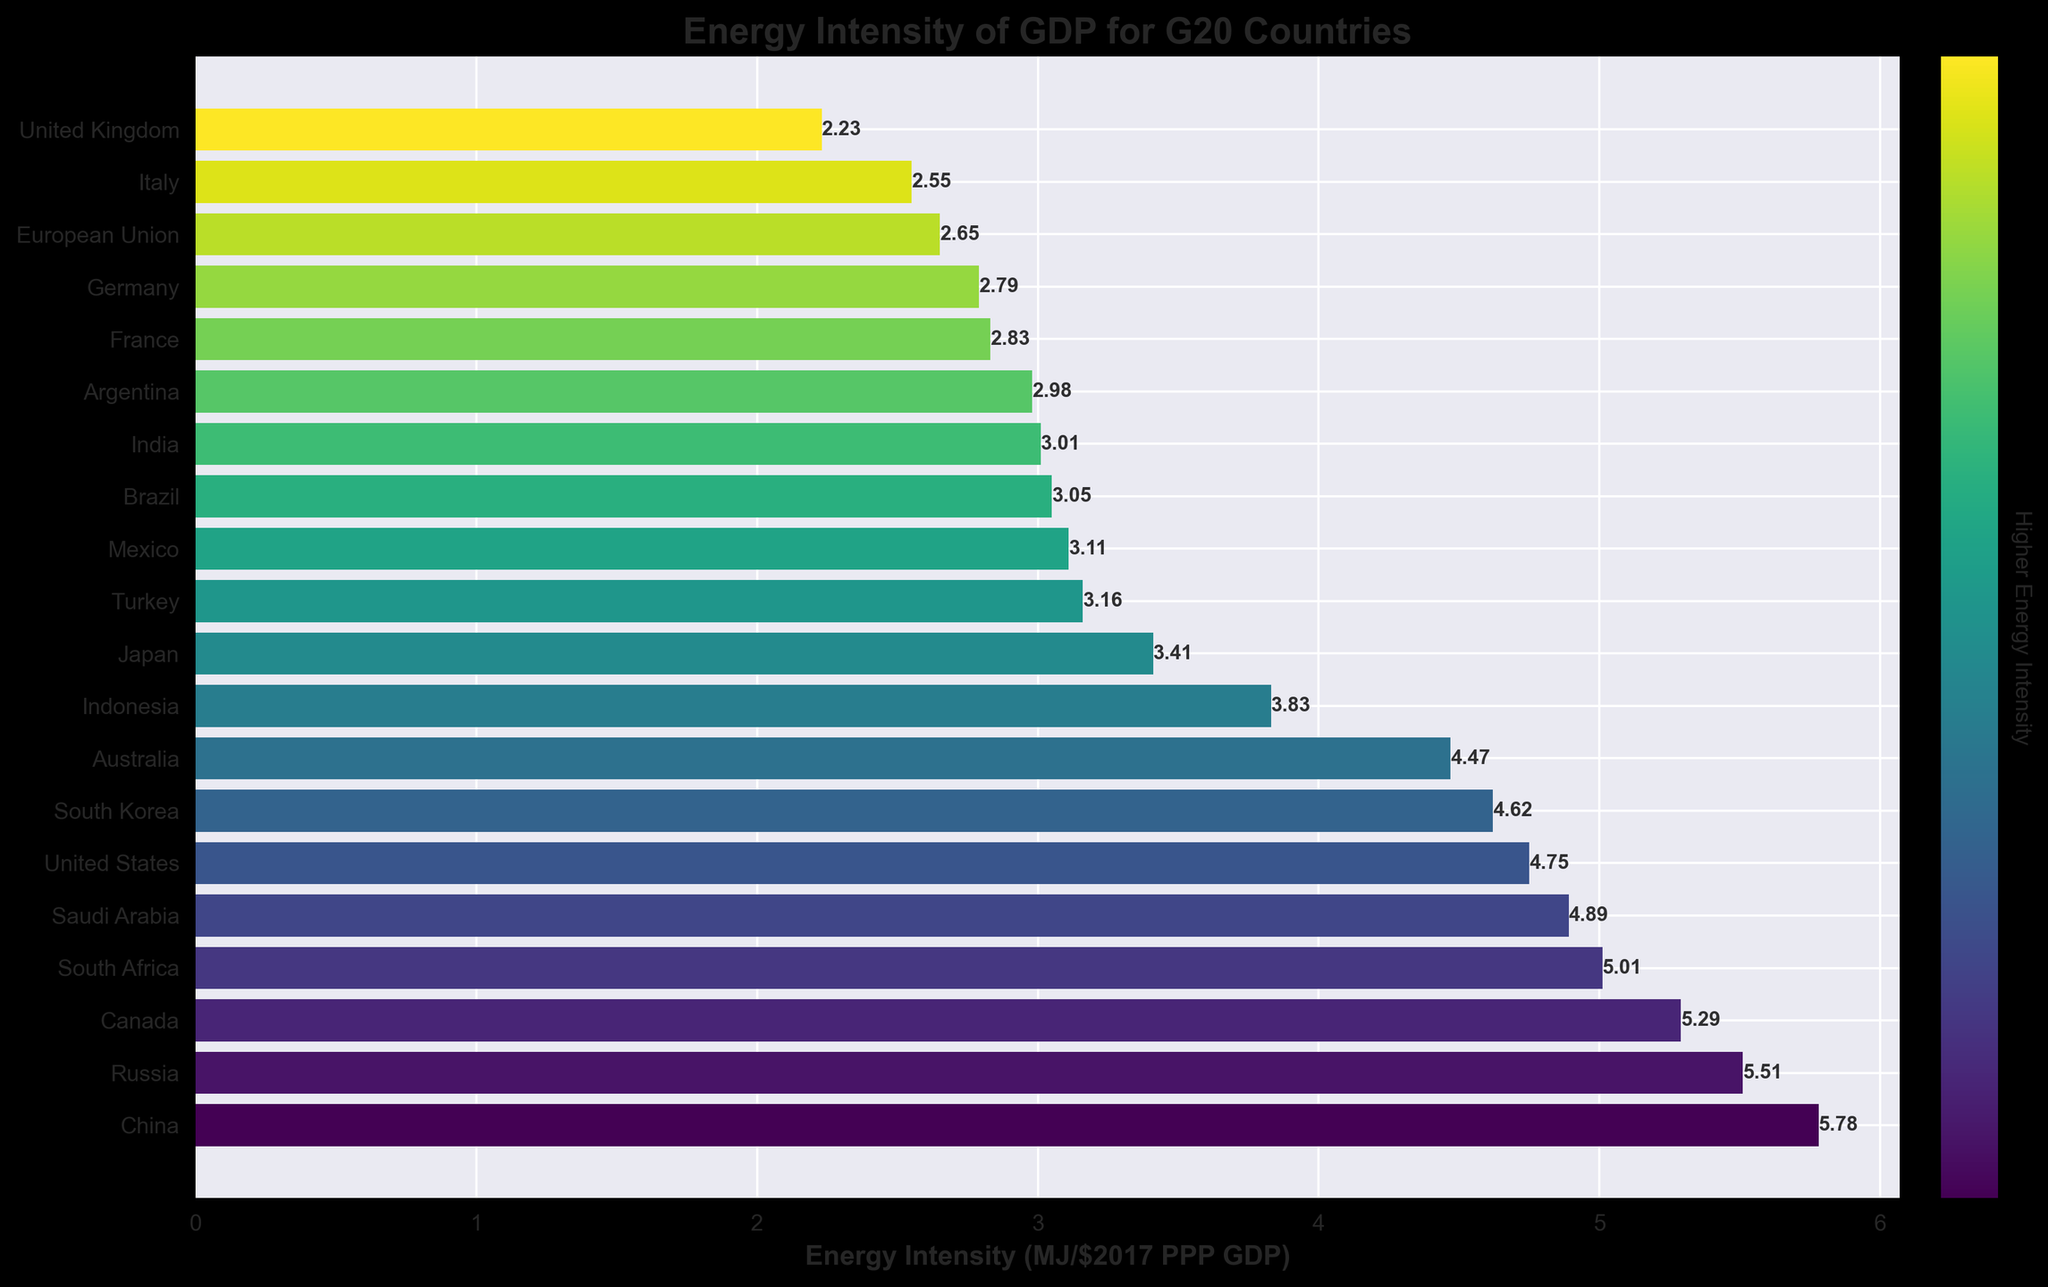Which country has the highest energy intensity? The bar representing China is the longest, indicating that it has the highest energy intensity.
Answer: China Among G20 countries, which has the lowest energy intensity? By observing the shortest bar, we see that the United Kingdom has the lowest energy intensity.
Answer: United Kingdom What is the difference in energy intensity between China and the United Kingdom? The energy intensity for China is 5.78 MJ/$2017 PPP GDP, and for the United Kingdom, it is 2.23 MJ/$2017 PPP GDP. The difference is 5.78 - 2.23.
Answer: 3.55 Compare the energy intensity of Russia and the United States. Which one is higher? The bar for Russia is longer than the one for the United States, indicating that Russia has a higher energy intensity.
Answer: Russia What is the average energy intensity for the top 5 countries in the chart? The top 5 countries are China (5.78), Russia (5.51), Canada (5.29), South Africa (5.01), and Saudi Arabia (4.89). The average is (5.78 + 5.51 + 5.29 + 5.01 + 4.89) / 5.
Answer: 5.30 Which country has an energy intensity closest to 4.00 MJ/$2017 PPP GDP? The bar for Indonesia is closest to the value of 4.00, with an energy intensity of 3.83 MJ/$2017 PPP GDP.
Answer: Indonesia Are there more G20 countries with energy intensity above or below 4.00 MJ/$2017 PPP GDP? By counting the bars, we see that 8 countries have an energy intensity above 4.00, and 12 countries have an energy intensity below 4.00. There are more countries below 4.00 MJ/$2017 PPP GDP.
Answer: Below What is the sum of the energy intensities for South Korea, Japan, and India? The energy intensities are South Korea (4.62), Japan (3.41), and India (3.01). The sum is 4.62 + 3.41 + 3.01.
Answer: 11.04 Which European country has the highest energy intensity among the G20 countries? By observing the bars representing European countries, France has the highest energy intensity.
Answer: France How does the energy intensity of the European Union compare to that of Germany? The bar for the European Union is slightly longer than the bar for Germany, indicating that the European Union has a higher energy intensity.
Answer: European Union 